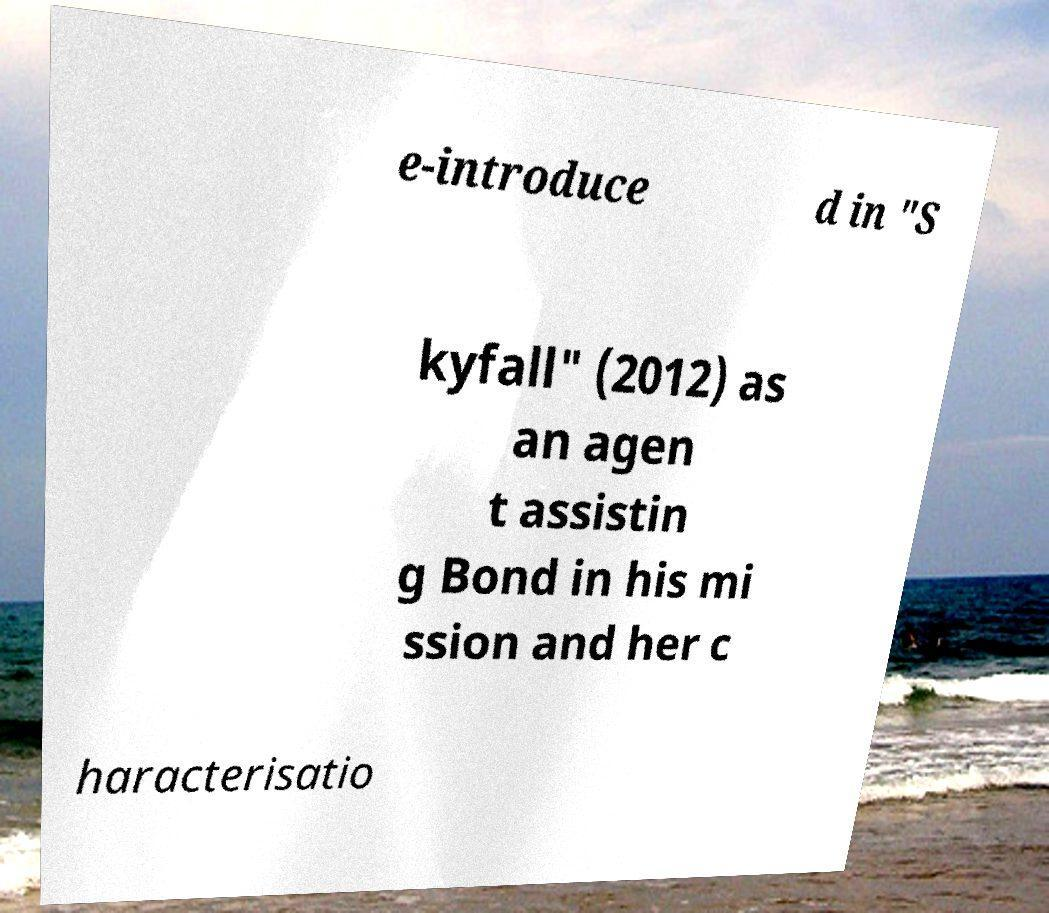There's text embedded in this image that I need extracted. Can you transcribe it verbatim? e-introduce d in "S kyfall" (2012) as an agen t assistin g Bond in his mi ssion and her c haracterisatio 